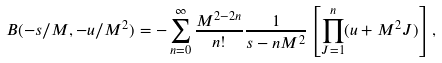<formula> <loc_0><loc_0><loc_500><loc_500>B ( - s / M , - u / M ^ { 2 } ) = - \sum _ { n = 0 } ^ { \infty } \frac { M ^ { 2 - 2 n } } { n ! } \frac { 1 } { s - n M ^ { 2 } } \left [ \prod _ { J = 1 } ^ { n } ( u + M ^ { 2 } J ) \right ] ,</formula> 